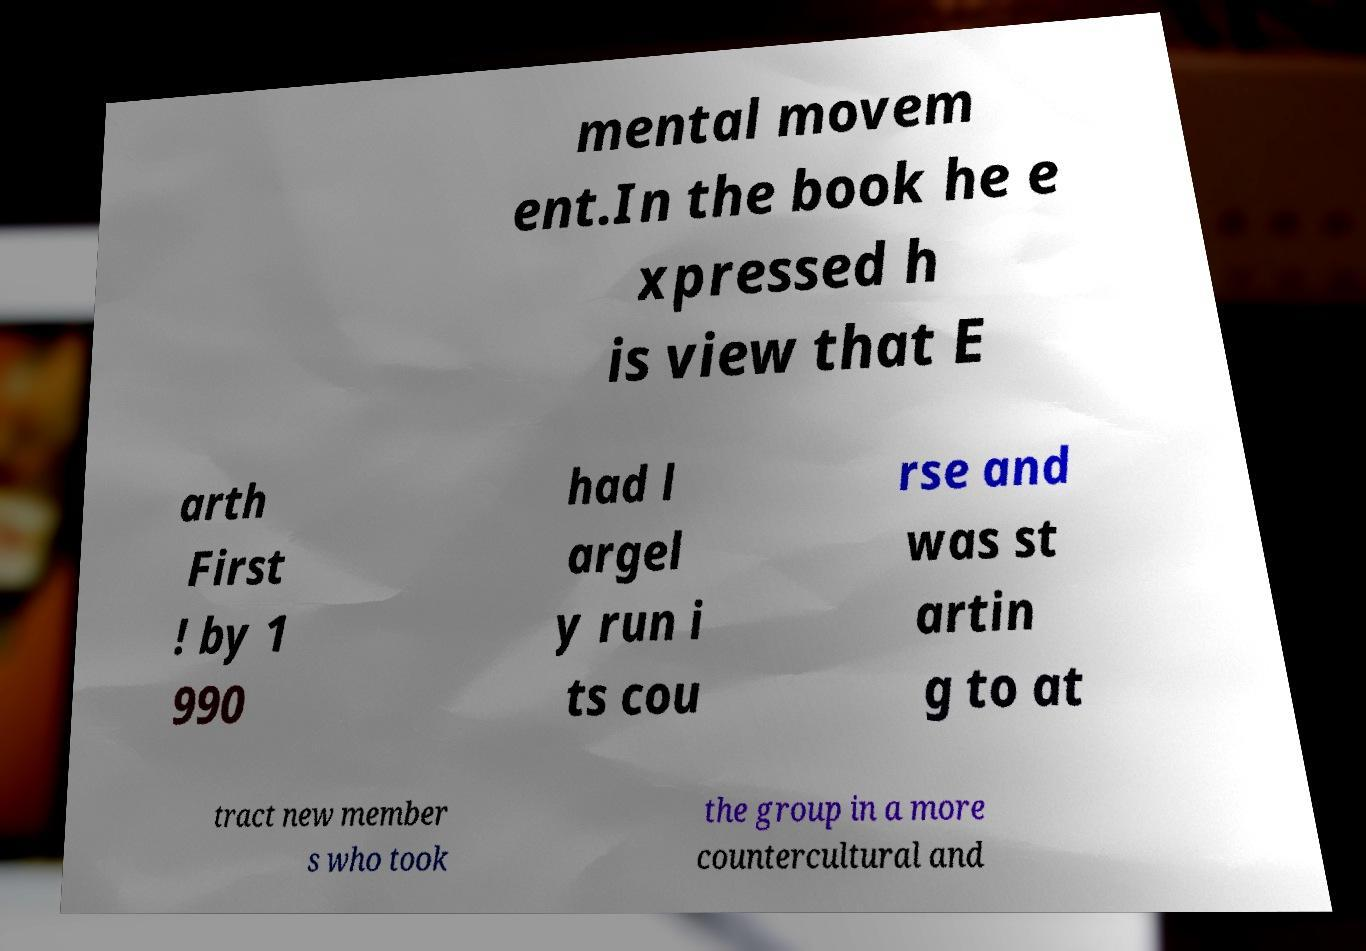Can you accurately transcribe the text from the provided image for me? mental movem ent.In the book he e xpressed h is view that E arth First ! by 1 990 had l argel y run i ts cou rse and was st artin g to at tract new member s who took the group in a more countercultural and 